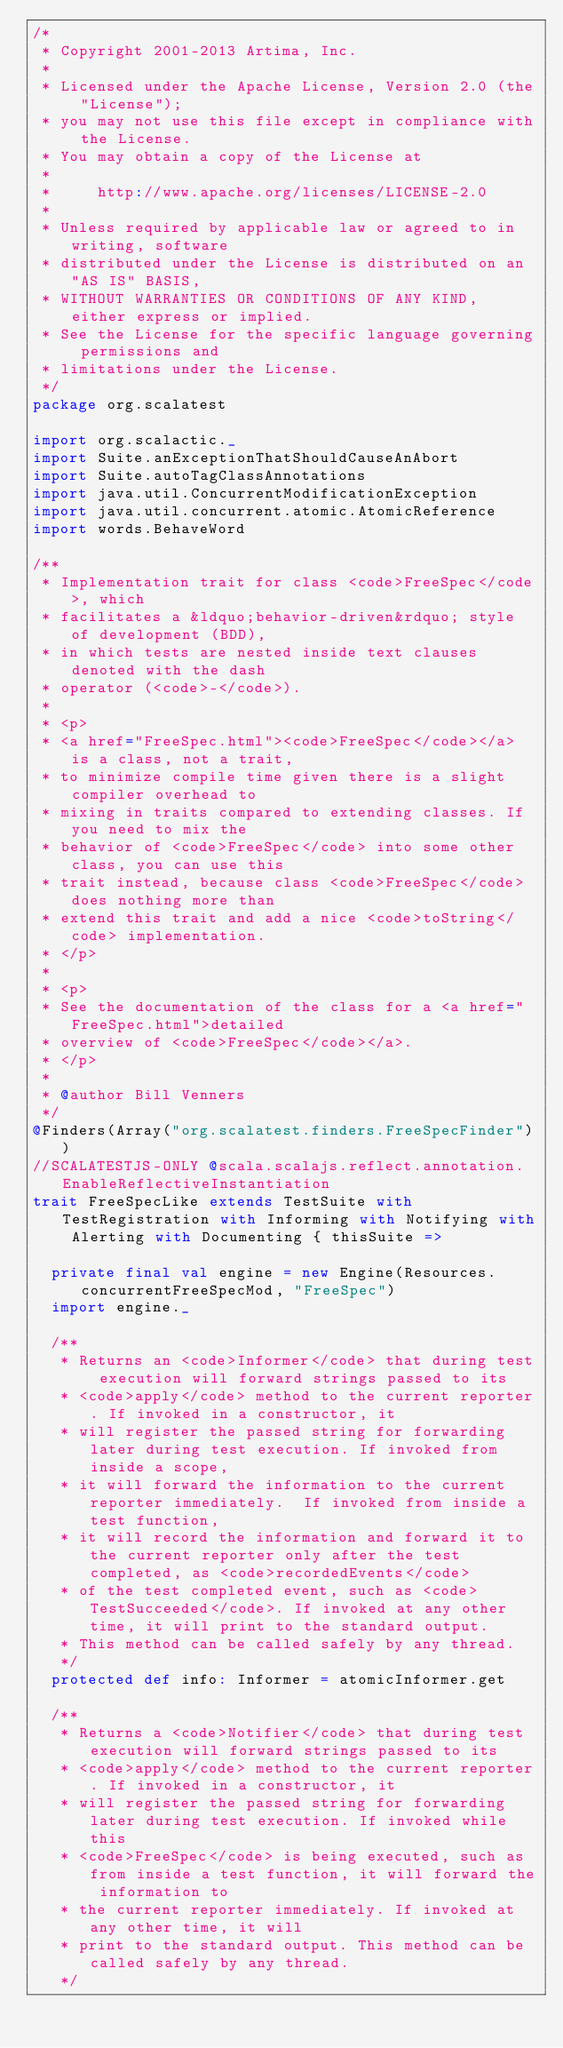<code> <loc_0><loc_0><loc_500><loc_500><_Scala_>/*
 * Copyright 2001-2013 Artima, Inc.
 *
 * Licensed under the Apache License, Version 2.0 (the "License");
 * you may not use this file except in compliance with the License.
 * You may obtain a copy of the License at
 *
 *     http://www.apache.org/licenses/LICENSE-2.0
 *
 * Unless required by applicable law or agreed to in writing, software
 * distributed under the License is distributed on an "AS IS" BASIS,
 * WITHOUT WARRANTIES OR CONDITIONS OF ANY KIND, either express or implied.
 * See the License for the specific language governing permissions and
 * limitations under the License.
 */
package org.scalatest

import org.scalactic._
import Suite.anExceptionThatShouldCauseAnAbort
import Suite.autoTagClassAnnotations
import java.util.ConcurrentModificationException
import java.util.concurrent.atomic.AtomicReference
import words.BehaveWord

/**
 * Implementation trait for class <code>FreeSpec</code>, which 
 * facilitates a &ldquo;behavior-driven&rdquo; style of development (BDD),
 * in which tests are nested inside text clauses denoted with the dash
 * operator (<code>-</code>).
 * 
 * <p>
 * <a href="FreeSpec.html"><code>FreeSpec</code></a> is a class, not a trait,
 * to minimize compile time given there is a slight compiler overhead to
 * mixing in traits compared to extending classes. If you need to mix the
 * behavior of <code>FreeSpec</code> into some other class, you can use this
 * trait instead, because class <code>FreeSpec</code> does nothing more than
 * extend this trait and add a nice <code>toString</code> implementation.
 * </p>
 *
 * <p>
 * See the documentation of the class for a <a href="FreeSpec.html">detailed
 * overview of <code>FreeSpec</code></a>.
 * </p>
 *
 * @author Bill Venners
 */
@Finders(Array("org.scalatest.finders.FreeSpecFinder"))
//SCALATESTJS-ONLY @scala.scalajs.reflect.annotation.EnableReflectiveInstantiation
trait FreeSpecLike extends TestSuite with TestRegistration with Informing with Notifying with Alerting with Documenting { thisSuite =>

  private final val engine = new Engine(Resources.concurrentFreeSpecMod, "FreeSpec")
  import engine._

  /**
   * Returns an <code>Informer</code> that during test execution will forward strings passed to its
   * <code>apply</code> method to the current reporter. If invoked in a constructor, it
   * will register the passed string for forwarding later during test execution. If invoked from inside a scope,
   * it will forward the information to the current reporter immediately.  If invoked from inside a test function,
   * it will record the information and forward it to the current reporter only after the test completed, as <code>recordedEvents</code>
   * of the test completed event, such as <code>TestSucceeded</code>. If invoked at any other time, it will print to the standard output.
   * This method can be called safely by any thread.
   */
  protected def info: Informer = atomicInformer.get

  /**
   * Returns a <code>Notifier</code> that during test execution will forward strings passed to its
   * <code>apply</code> method to the current reporter. If invoked in a constructor, it
   * will register the passed string for forwarding later during test execution. If invoked while this
   * <code>FreeSpec</code> is being executed, such as from inside a test function, it will forward the information to
   * the current reporter immediately. If invoked at any other time, it will
   * print to the standard output. This method can be called safely by any thread.
   */</code> 